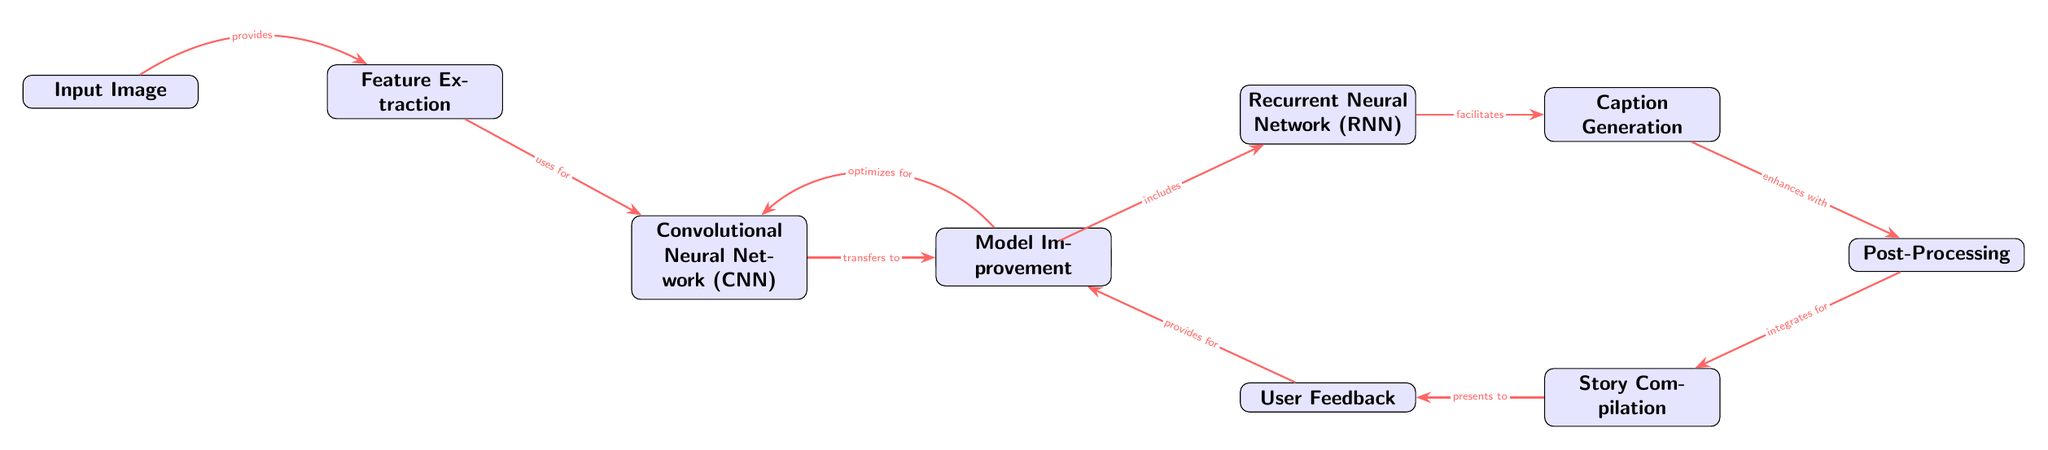What is the first node in the diagram? The first node is labeled "Input Image," which is clearly marked as the starting point of the process in the diagram.
Answer: Input Image How many nodes are present in the diagram? By counting the boxes labeled in the diagram, there are a total of ten nodes depicted.
Answer: 10 Which node connects the "Feature Extraction" node to the "Language Model" node? Referring to the arrows in the diagram, the "Convolutional Neural Network (CNN)" node is the one that connects "Feature Extraction" to "Language Model."
Answer: Convolutional Neural Network (CNN) What is the function of the "Post-Processing" node? The "Post-Processing" node is indicated to enhance the flow from "Caption Generation," meaning it serves a supplementary role within the process.
Answer: Enhances How does user feedback contribute to the diagram? The "User Feedback" node provides inputs that are presented to the "Model Improvement" node, indicating its role in optimization.
Answer: Provides for Which node follows the "Caption Generation" node? The node that follows "Caption Generation" is "Post-Processing," as shown by the direct arrow leading from one to the other.
Answer: Post-Processing What relationship does the "Convolutional Neural Network (CNN)" node have with the "Feature Extraction" node? The relationship demonstrated is that "Feature Extraction" uses the output from the "Convolutional Neural Network (CNN)" for further processing.
Answer: Uses for How does the diagram cycle back for model improvement? The diagram shows that "Model Improvement" provides feedback to the "Convolutional Neural Network (CNN)" node, creating an optimization loop.
Answer: Optimizes for What type of model is represented in the "Language Model" node? The "Language Model" refers to a broad class of models designed to understand and generate human language, specifically in this context likely to use RNN architectures.
Answer: RNN 